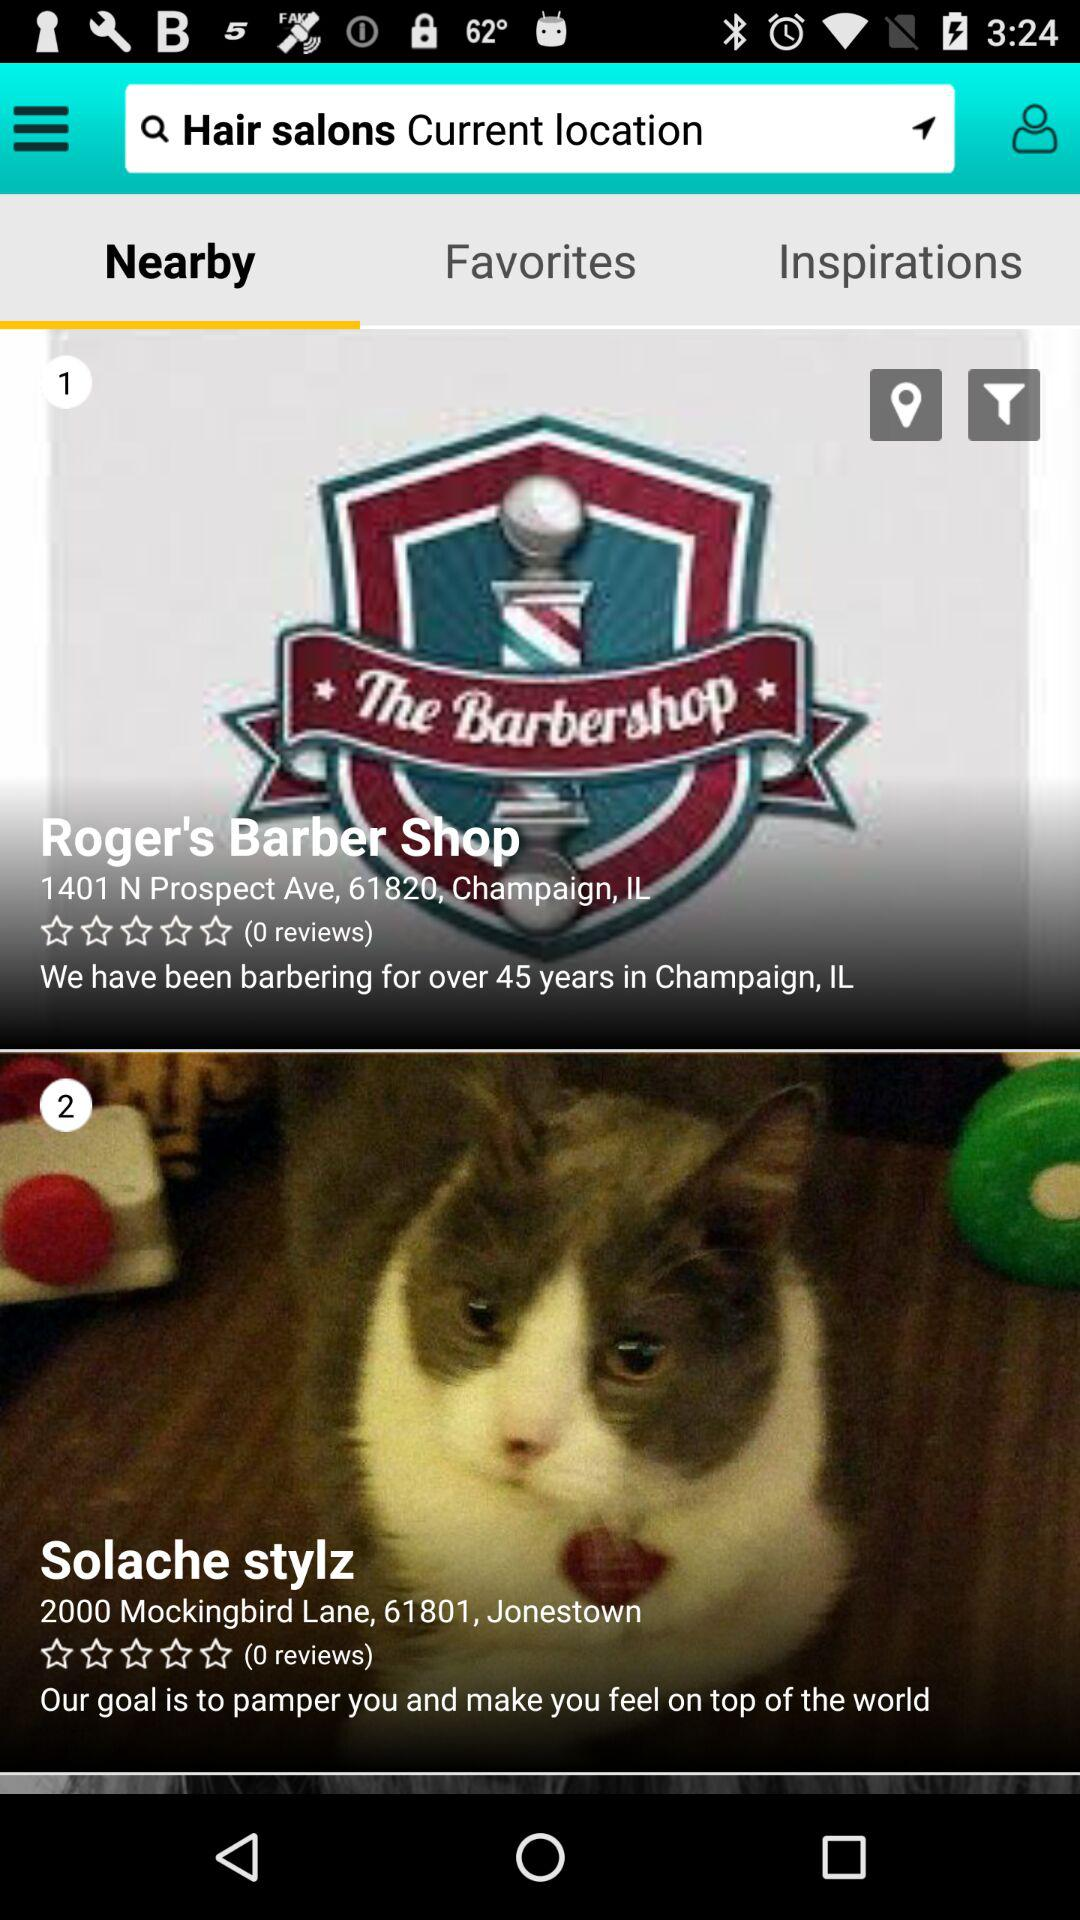What is the address of the Solache stylz? The address of the Solache stylz is 2000 Mockingbird Lane, 61801, Jonestown. 